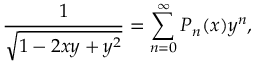Convert formula to latex. <formula><loc_0><loc_0><loc_500><loc_500>{ \frac { 1 } { \sqrt { 1 - 2 x y + y ^ { 2 } } } } = \sum _ { n = 0 } ^ { \infty } P _ { n } ( x ) y ^ { n } ,</formula> 